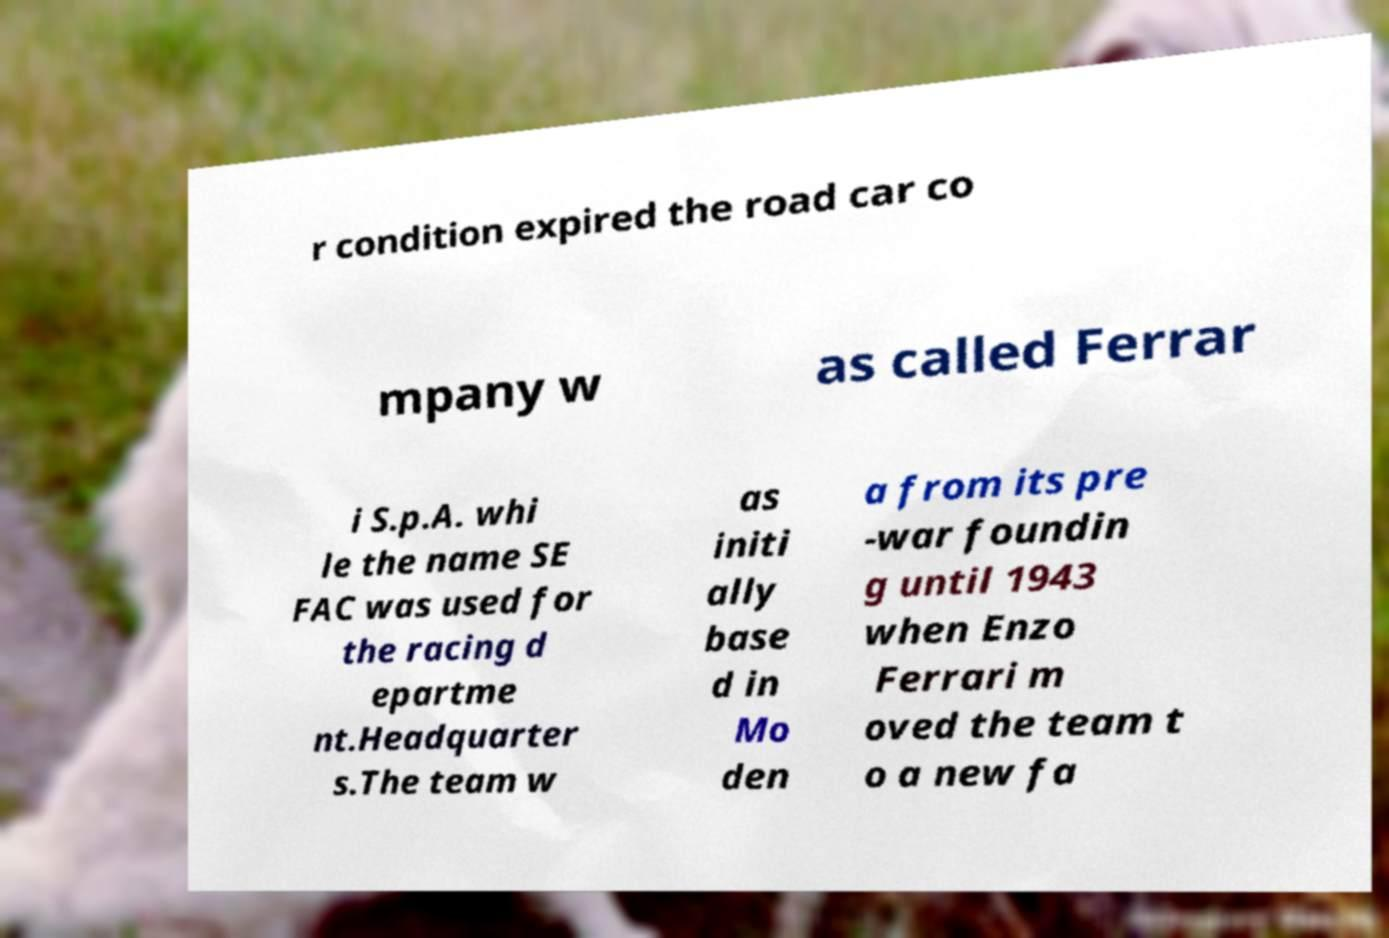Please read and relay the text visible in this image. What does it say? r condition expired the road car co mpany w as called Ferrar i S.p.A. whi le the name SE FAC was used for the racing d epartme nt.Headquarter s.The team w as initi ally base d in Mo den a from its pre -war foundin g until 1943 when Enzo Ferrari m oved the team t o a new fa 